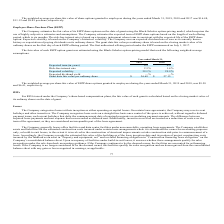According to Mimecast Limited's financial document, Which model is used to estimate fair value of its ESPP share options on the date of grant ? Black-Scholes option-pricing model. The document states: "ESPP share options on the date of grant using the Black-Scholes option-pricing model, which requires the..." Also, What is the risk free interest rate based on? a treasury instrument whose term is consistent with the expected life of the ESPP share option.. The document states: "ix months. The risk-free interest rate is based on a treasury instrument whose term is consistent with the expected life of the ESPP share option. Exp..." Also, What was the Expected term (in years) in 2019 and 2018 respectively? The document shows two values: 0.5 and 0.5. From the document: "Expected term (in years) 0.5 0.5..." Also, can you calculate: What was the change in the Risk-free interest rate from 2018 to 2019? Based on the calculation: 2.3 - 1.4, the result is 0.9 (percentage). This is based on the information: "Risk-free interest rate 2.3% 1.4% Risk-free interest rate 2.3% 1.4%..." The key data points involved are: 1.4, 2.3. Also, can you calculate: What is the average Expected volatility for 2018 and 2019? To answer this question, I need to perform calculations using the financial data. The calculation is: (39.1 + 29.9) / 2, which equals 34.5 (percentage). This is based on the information: "Expected volatility 39.1% 29.9% Expected volatility 39.1% 29.9%..." The key data points involved are: 29.9, 39.1. Additionally, In which year was the Grant date fair value per ordinary share less than 30.0? According to the financial document, 2018. The relevant text states: "2019 2018..." 